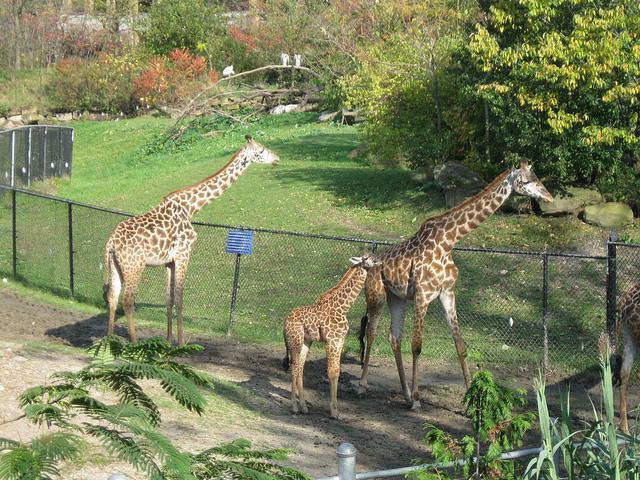How many baby giraffes are in the picture?
Give a very brief answer. 1. How many giraffes can be seen?
Give a very brief answer. 4. 